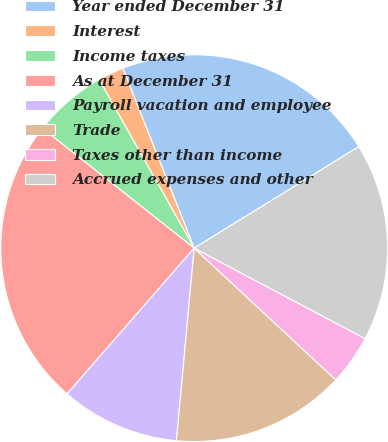Convert chart. <chart><loc_0><loc_0><loc_500><loc_500><pie_chart><fcel>Year ended December 31<fcel>Interest<fcel>Income taxes<fcel>As at December 31<fcel>Payroll vacation and employee<fcel>Trade<fcel>Taxes other than income<fcel>Accrued expenses and other<nl><fcel>22.22%<fcel>2.17%<fcel>6.18%<fcel>24.23%<fcel>9.95%<fcel>14.53%<fcel>4.18%<fcel>16.54%<nl></chart> 